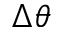<formula> <loc_0><loc_0><loc_500><loc_500>\Delta \theta</formula> 